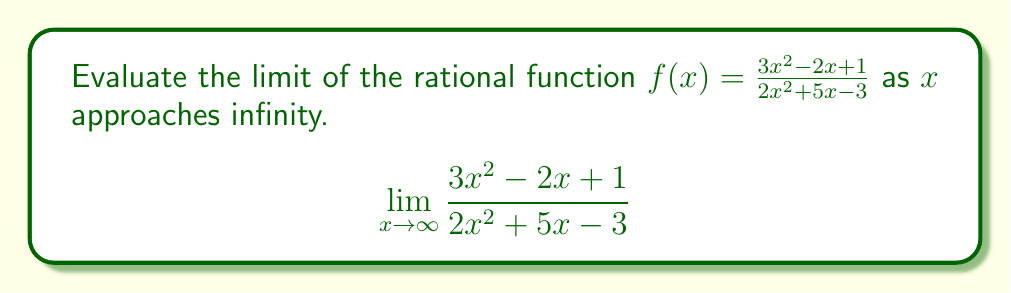Could you help me with this problem? To evaluate this limit, we'll follow these steps:

1) First, we identify the highest degree terms in both the numerator and denominator. In this case, both have degree 2.

2) When the degrees are equal, the limit will be the ratio of the coefficients of the highest degree terms:

   $$\lim_{x \to \infty} \frac{3x^2 - 2x + 1}{2x^2 + 5x - 3} = \frac{3}{2}$$

3) To understand why this works, we can divide both numerator and denominator by $x^2$ (the highest power):

   $$\lim_{x \to \infty} \frac{3x^2 - 2x + 1}{2x^2 + 5x - 3} = \lim_{x \to \infty} \frac{3 - \frac{2}{x} + \frac{1}{x^2}}{2 + \frac{5}{x} - \frac{3}{x^2}}$$

4) As $x$ approaches infinity, $\frac{1}{x}$ and $\frac{1}{x^2}$ approach 0:

   $$\lim_{x \to \infty} \frac{3 - 0 + 0}{2 + 0 - 0} = \frac{3}{2}$$

Therefore, the limit of the function as $x$ approaches infinity is $\frac{3}{2}$.
Answer: $\frac{3}{2}$ 